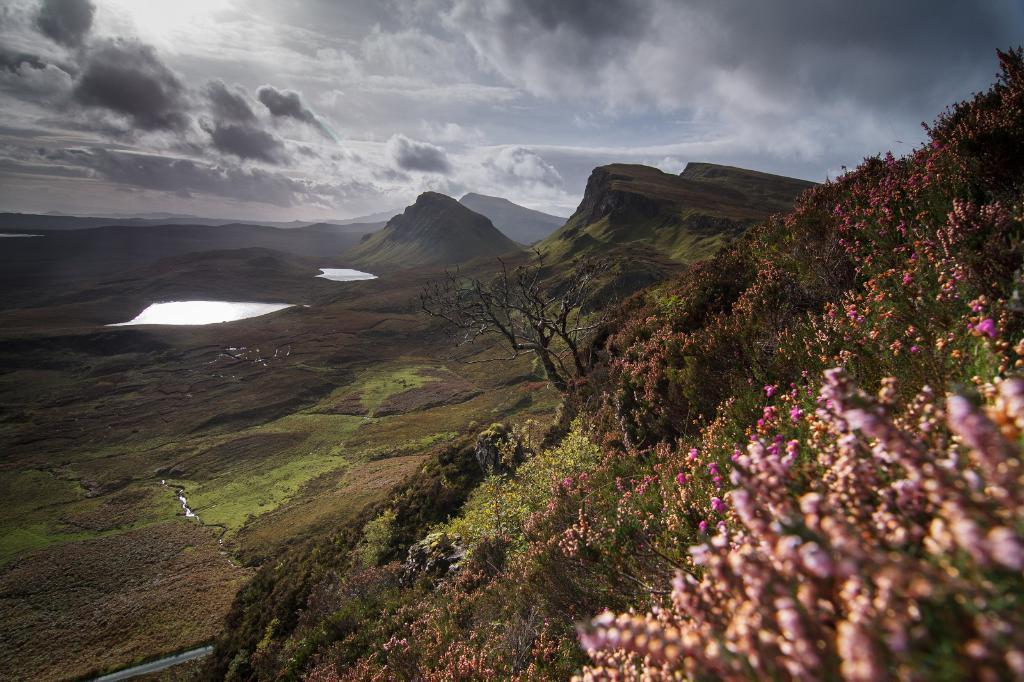What type of water is present in the image? There is groundwater in the image. What geographical features can be seen in the image? There are mountains in the image. What type of vegetation is present in the image? There are trees and flowers in the image. What is visible in the background of the image? The sky is visible in the background of the image, and there are clouds in the sky. How many friends are sitting on the heart in the image? There is no heart or friends present in the image. 